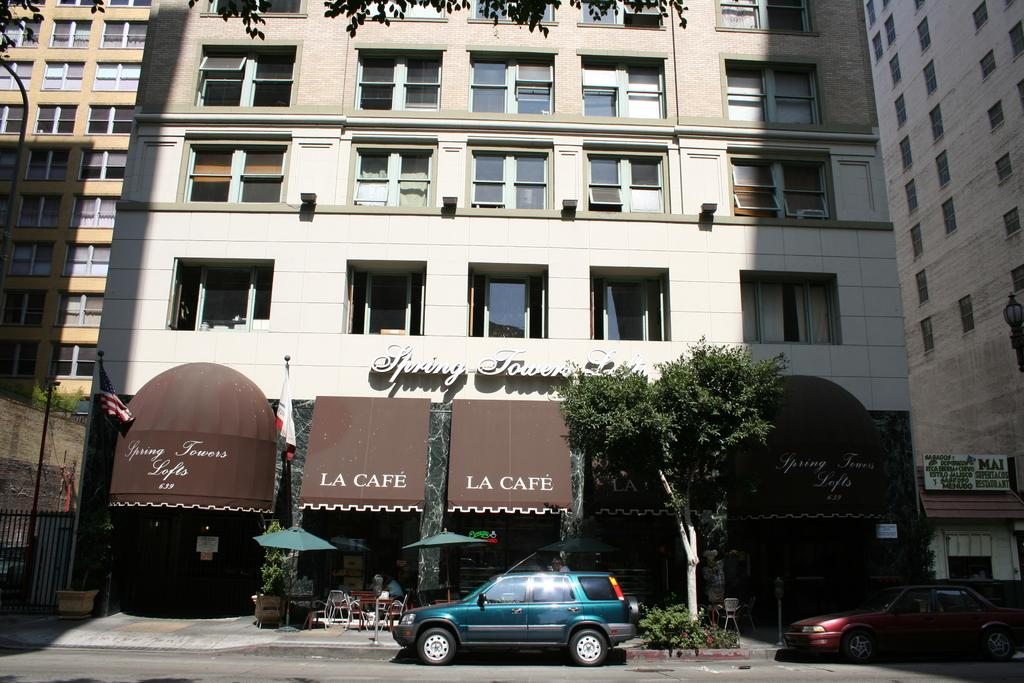What type of structures can be seen in the image? There are buildings in the image. What natural elements are present in the image? There are trees and plants in the image. What objects are used for protection from the sun or rain in the image? There are umbrellas in the image. What objects are used for sitting in the image? There are chairs in the image. What type of vehicles can be seen in the image? There are cars in the image. What type of feet can be seen walking on the grass in the image? There are no feet or people walking in the image; it only shows buildings, trees, umbrellas, chairs, plants, and cars. What religious belief is being practiced in the image? There is no indication of any religious belief being practiced in the image. 